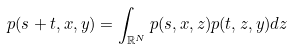<formula> <loc_0><loc_0><loc_500><loc_500>p ( s + t , x , y ) = \int _ { \mathbb { R } ^ { N } } p ( s , x , z ) p ( t , z , y ) d z</formula> 